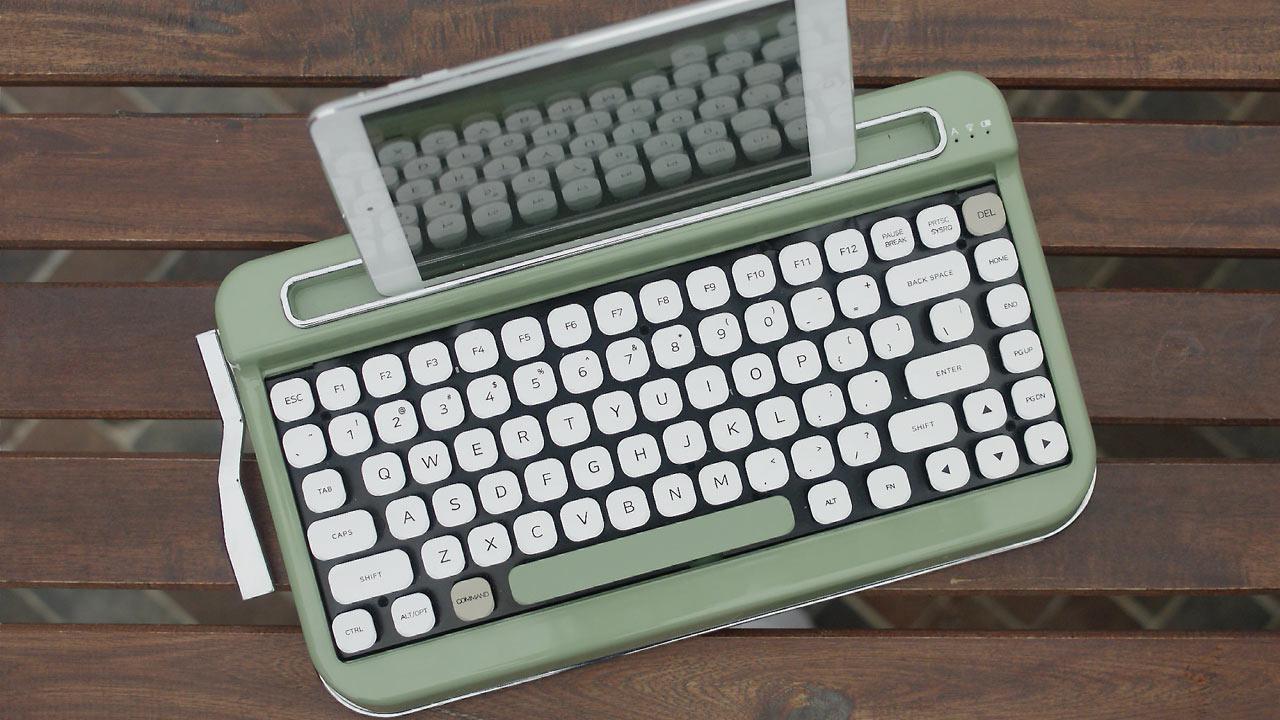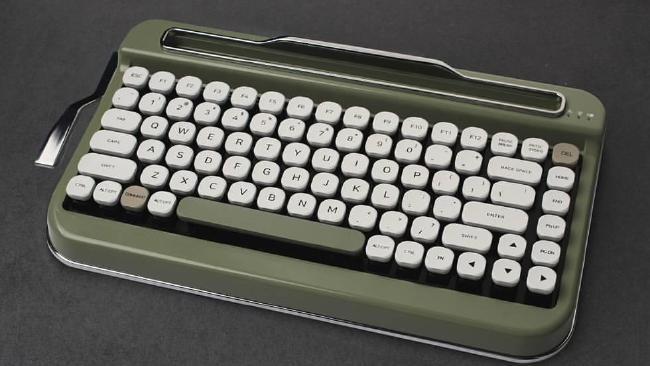The first image is the image on the left, the second image is the image on the right. For the images shown, is this caption "Several keyboards appear in at least one of the images." true? Answer yes or no. No. 